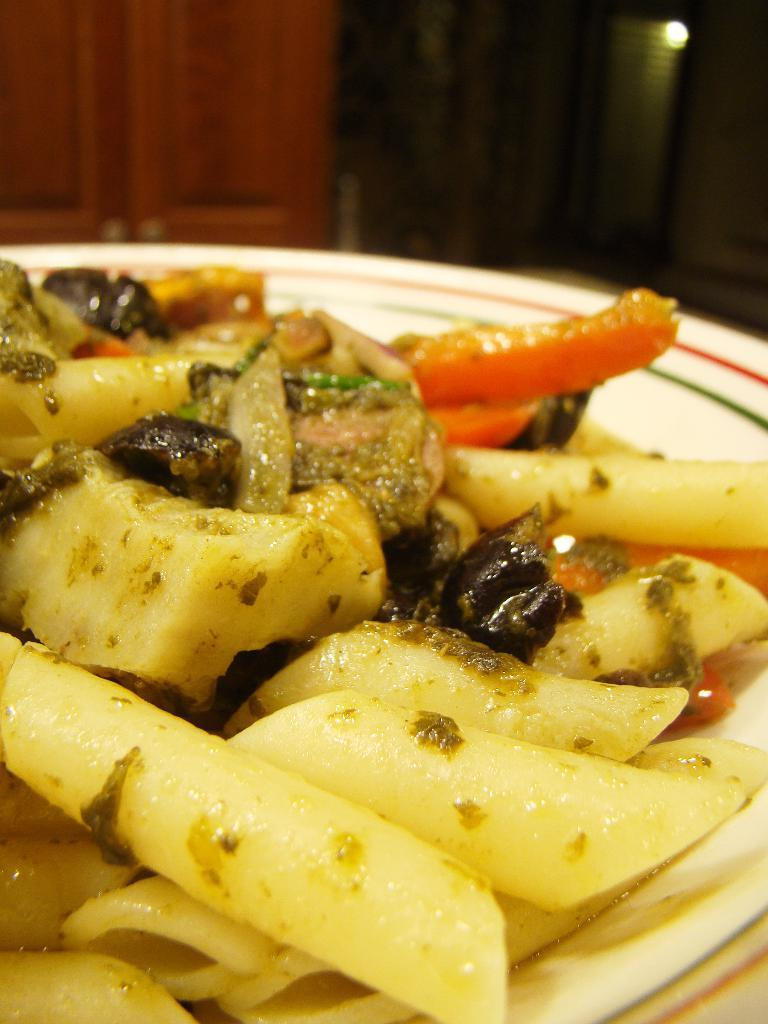What object is present on the plate in the image? There are food items on the plate in the image. Can you describe the appearance of the food items? Unfortunately, the provided facts do not give any details about the appearance of the food items. What can be observed about the background of the image? The background of the image is blurred. What source of illumination is visible in the image? There is a light visible in the image. What type of apparatus is used to create a sense of comfort in the image? There is no apparatus present in the image that is designed to create a sense of comfort. 